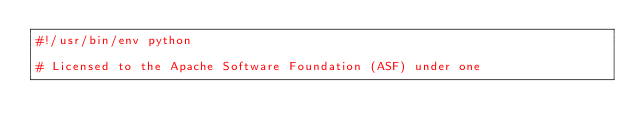<code> <loc_0><loc_0><loc_500><loc_500><_Python_>#!/usr/bin/env python

# Licensed to the Apache Software Foundation (ASF) under one</code> 